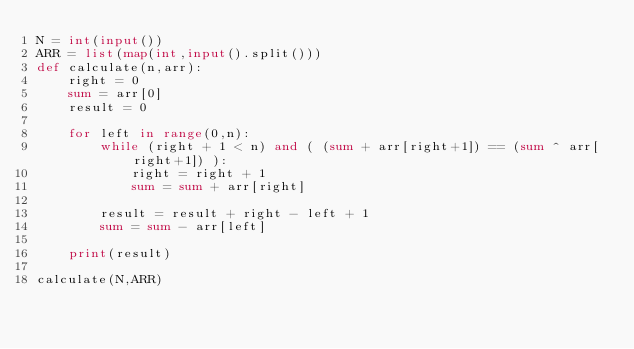Convert code to text. <code><loc_0><loc_0><loc_500><loc_500><_Python_>N = int(input())
ARR = list(map(int,input().split()))
def calculate(n,arr):
    right = 0
    sum = arr[0]
    result = 0

    for left in range(0,n):
        while (right + 1 < n) and ( (sum + arr[right+1]) == (sum ^ arr[right+1]) ):
            right = right + 1
            sum = sum + arr[right]

        result = result + right - left + 1
        sum = sum - arr[left]

    print(result)

calculate(N,ARR)</code> 